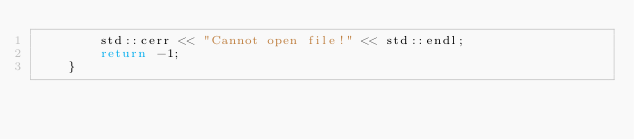<code> <loc_0><loc_0><loc_500><loc_500><_C++_>		std::cerr << "Cannot open file!" << std::endl;
		return -1;
	}</code> 